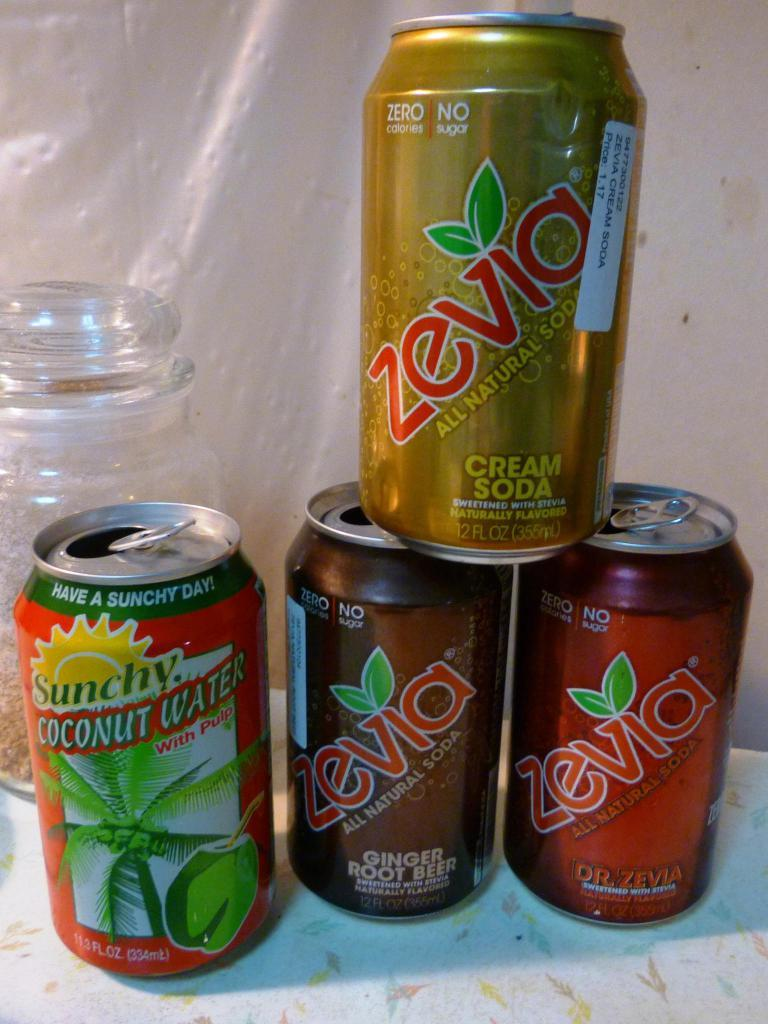<image>
Write a terse but informative summary of the picture. a zevia can that is on top of others 